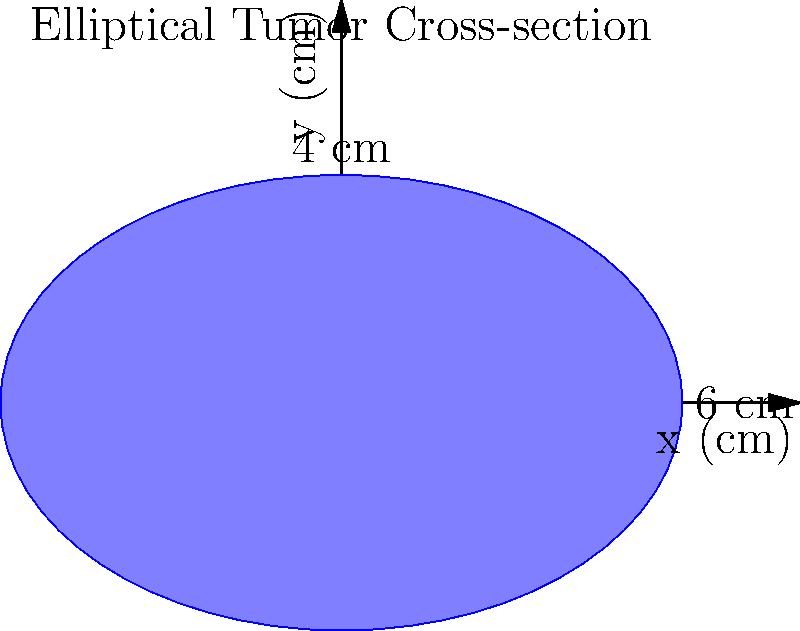An elliptical tumor with a major axis of 6 cm and a minor axis of 4 cm is being treated with radiation therapy. The tumor receives a uniform dose rate of 2 Gy/min across its entire cross-section. If the treatment time is 5 minutes, what is the total absorbed radiation dose in the tumor, and what is the total energy deposited in the tumor tissue, given that the tumor's density is 1.06 g/cm³? To solve this problem, we'll follow these steps:

1. Calculate the absorbed dose:
   - Dose rate = 2 Gy/min
   - Treatment time = 5 min
   - Total absorbed dose = Dose rate × Treatment time
   - Total absorbed dose = 2 Gy/min × 5 min = 10 Gy

2. Calculate the tumor volume:
   - Volume of an ellipsoid = $\frac{4}{3}\pi abc$, where a, b, and c are the semi-axes
   - In this case, a = 3 cm, b = 2 cm, and we'll assume c = 2 cm (as we only have 2D information)
   - Volume = $\frac{4}{3}\pi(3)(2)(2) = 16\pi$ cm³

3. Calculate the tumor mass:
   - Density = 1.06 g/cm³
   - Mass = Density × Volume
   - Mass = 1.06 g/cm³ × $16\pi$ cm³ ≈ 53.4 g

4. Calculate the total energy deposited:
   - Energy = Dose × Mass
   - 1 Gy = 1 J/kg = 0.001 J/g
   - Energy = 10 Gy × 53.4 g × 0.001 J/g/Gy = 0.534 J

Therefore, the total absorbed radiation dose is 10 Gy, and the total energy deposited in the tumor tissue is approximately 0.534 J.
Answer: 10 Gy; 0.534 J 